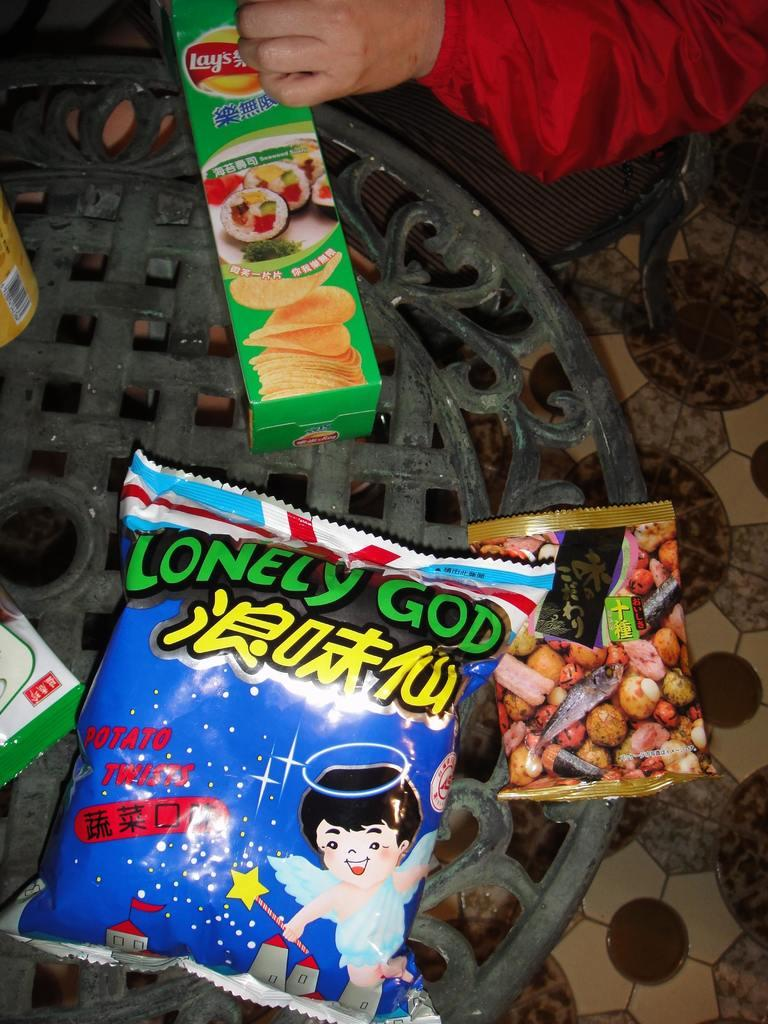What objects are on the table in the image? There are packets on a table in the image. Can you describe the person in the image? There is a person sitting on a chair in the image. Where is the chair located in relation to the table? The chair is beside the table. What type of butter is being spread on the hill in the image? There is no hill or butter present in the image; it only features packets on a table and a person sitting on a chair. 